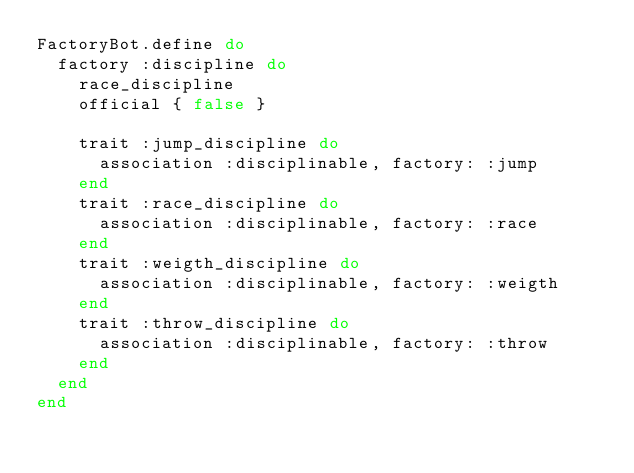Convert code to text. <code><loc_0><loc_0><loc_500><loc_500><_Ruby_>FactoryBot.define do
  factory :discipline do
    race_discipline
    official { false }
    
    trait :jump_discipline do
      association :disciplinable, factory: :jump
    end
    trait :race_discipline do
      association :disciplinable, factory: :race
    end
    trait :weigth_discipline do
      association :disciplinable, factory: :weigth
    end
    trait :throw_discipline do
      association :disciplinable, factory: :throw
    end
  end
end
</code> 